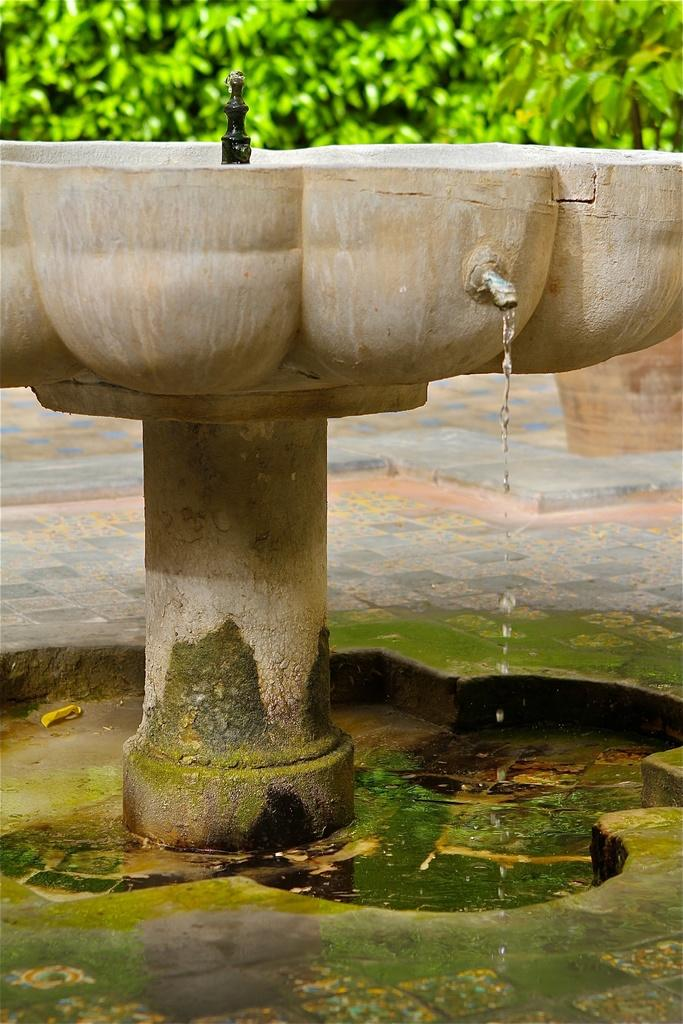What can be found in the image that is used for washing or cleaning? There is a sink in the image that can be used for washing or cleaning. What type of vegetation is visible in the image? There are green trees visible in the image. What else can be seen in the image besides the sink and trees? There is water visible in the image. Can you see a fireman putting out a fire with a lip in the image? No, there is no fireman, fire, or lip present in the image. 